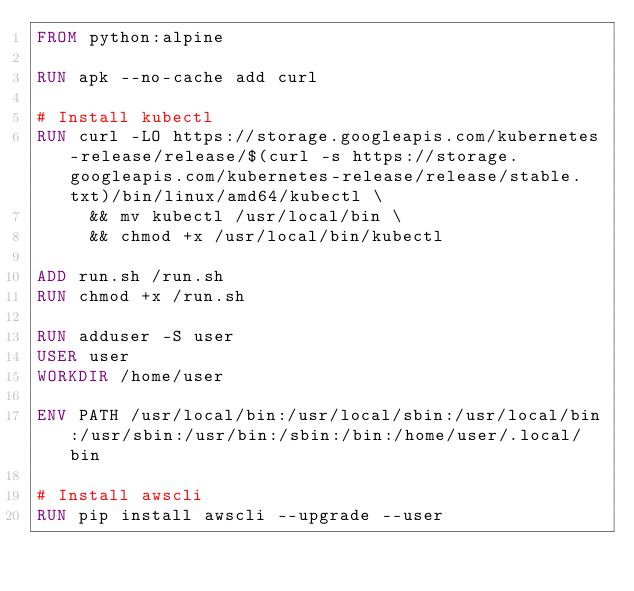Convert code to text. <code><loc_0><loc_0><loc_500><loc_500><_Dockerfile_>FROM python:alpine

RUN apk --no-cache add curl

# Install kubectl
RUN curl -LO https://storage.googleapis.com/kubernetes-release/release/$(curl -s https://storage.googleapis.com/kubernetes-release/release/stable.txt)/bin/linux/amd64/kubectl \
	 && mv kubectl /usr/local/bin \
	 && chmod +x /usr/local/bin/kubectl

ADD run.sh /run.sh
RUN chmod +x /run.sh

RUN adduser -S user
USER user
WORKDIR /home/user

ENV PATH /usr/local/bin:/usr/local/sbin:/usr/local/bin:/usr/sbin:/usr/bin:/sbin:/bin:/home/user/.local/bin

# Install awscli
RUN pip install awscli --upgrade --user
</code> 